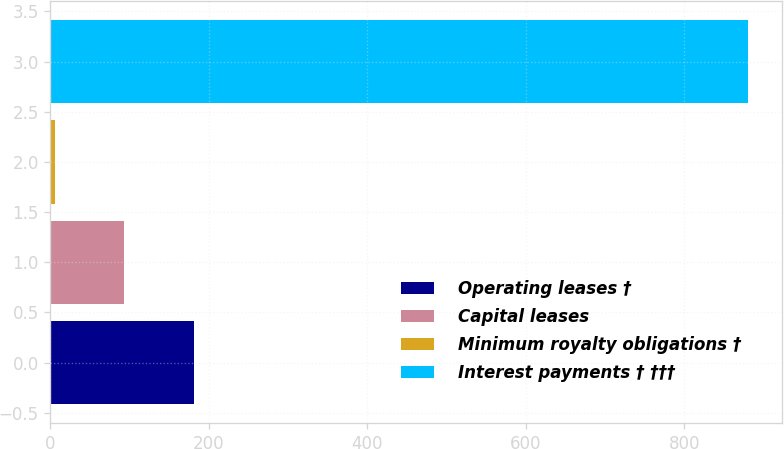Convert chart. <chart><loc_0><loc_0><loc_500><loc_500><bar_chart><fcel>Operating leases †<fcel>Capital leases<fcel>Minimum royalty obligations †<fcel>Interest payments † †††<nl><fcel>180.8<fcel>93.4<fcel>6<fcel>880<nl></chart> 